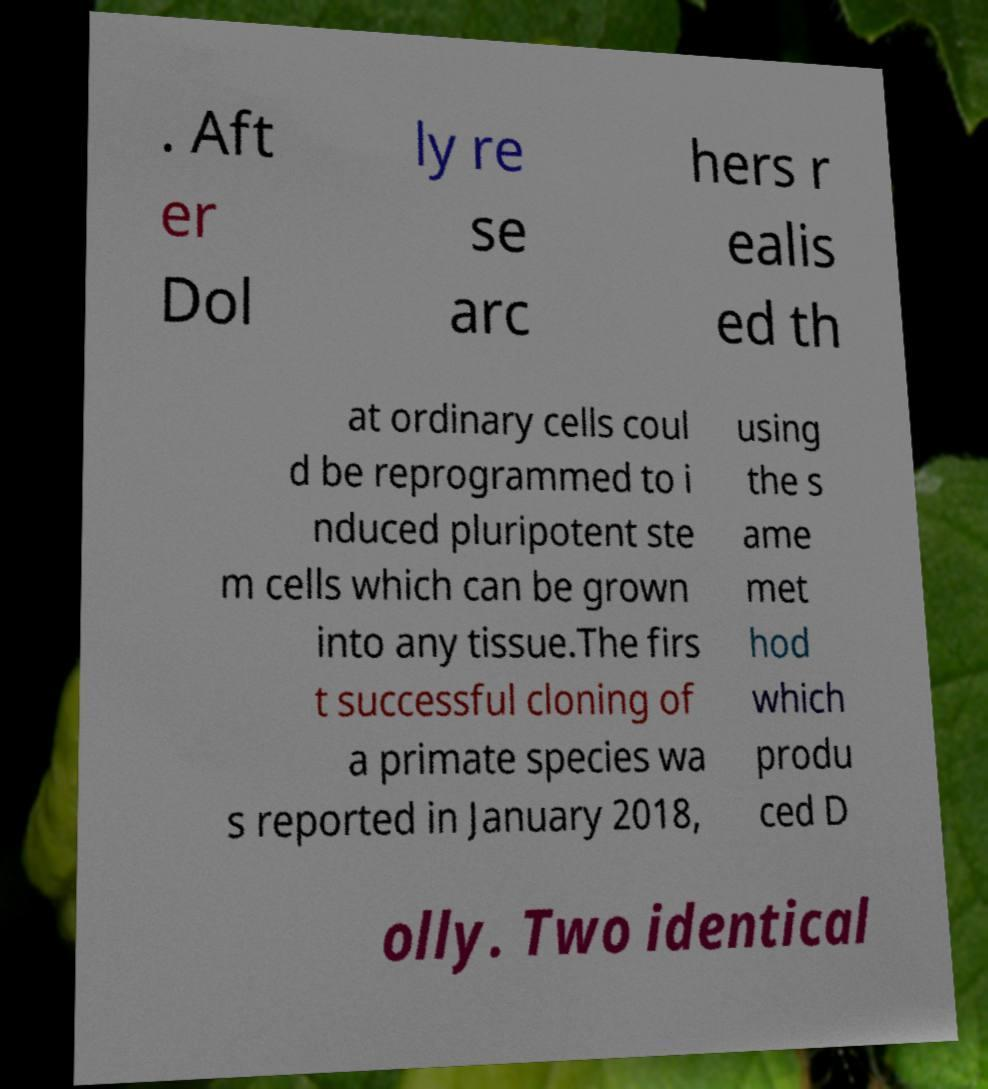Please identify and transcribe the text found in this image. . Aft er Dol ly re se arc hers r ealis ed th at ordinary cells coul d be reprogrammed to i nduced pluripotent ste m cells which can be grown into any tissue.The firs t successful cloning of a primate species wa s reported in January 2018, using the s ame met hod which produ ced D olly. Two identical 